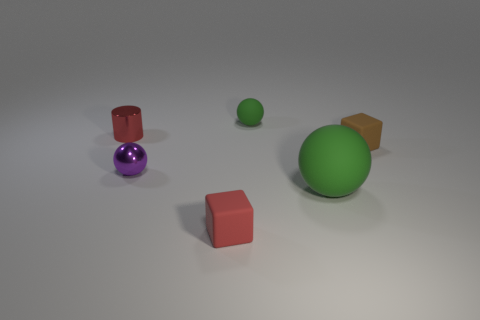Can you describe the positioning of the objects in the image? Certainly! In the image, we have a large green ball positioned centrally. To its left, there's a smaller purple ball. Directly in front of the green ball, closer to the viewpoint, is a small red cube, and to the right of the red cube, there is a small green ball. Lastly, to the right of the large green ball and slightly behind it, is an orange cube. 